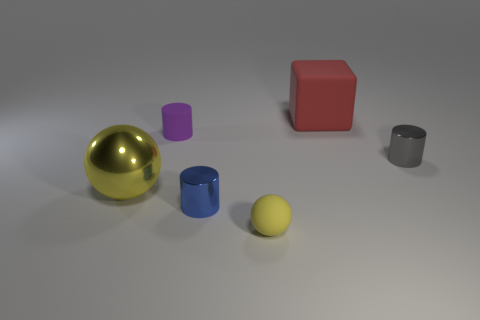What is the material of the small object that is the same color as the large ball?
Give a very brief answer. Rubber. How many objects are big objects behind the small gray metal object or tiny objects on the right side of the tiny blue thing?
Your answer should be very brief. 3. Do the metal thing that is behind the big shiny ball and the metallic cylinder that is to the left of the large matte block have the same size?
Your response must be concise. Yes. Are there any matte things that are on the left side of the yellow thing on the left side of the matte cylinder?
Ensure brevity in your answer.  No. There is a cube; how many purple cylinders are behind it?
Keep it short and to the point. 0. What number of other things are there of the same color as the small rubber sphere?
Your response must be concise. 1. Are there fewer big objects in front of the big yellow metallic sphere than rubber cylinders that are on the left side of the rubber cube?
Keep it short and to the point. Yes. How many objects are small matte objects that are behind the tiny blue cylinder or large blue spheres?
Offer a very short reply. 1. Is the size of the block the same as the yellow sphere that is left of the matte ball?
Make the answer very short. Yes. The gray thing that is the same shape as the small blue metal thing is what size?
Provide a short and direct response. Small. 